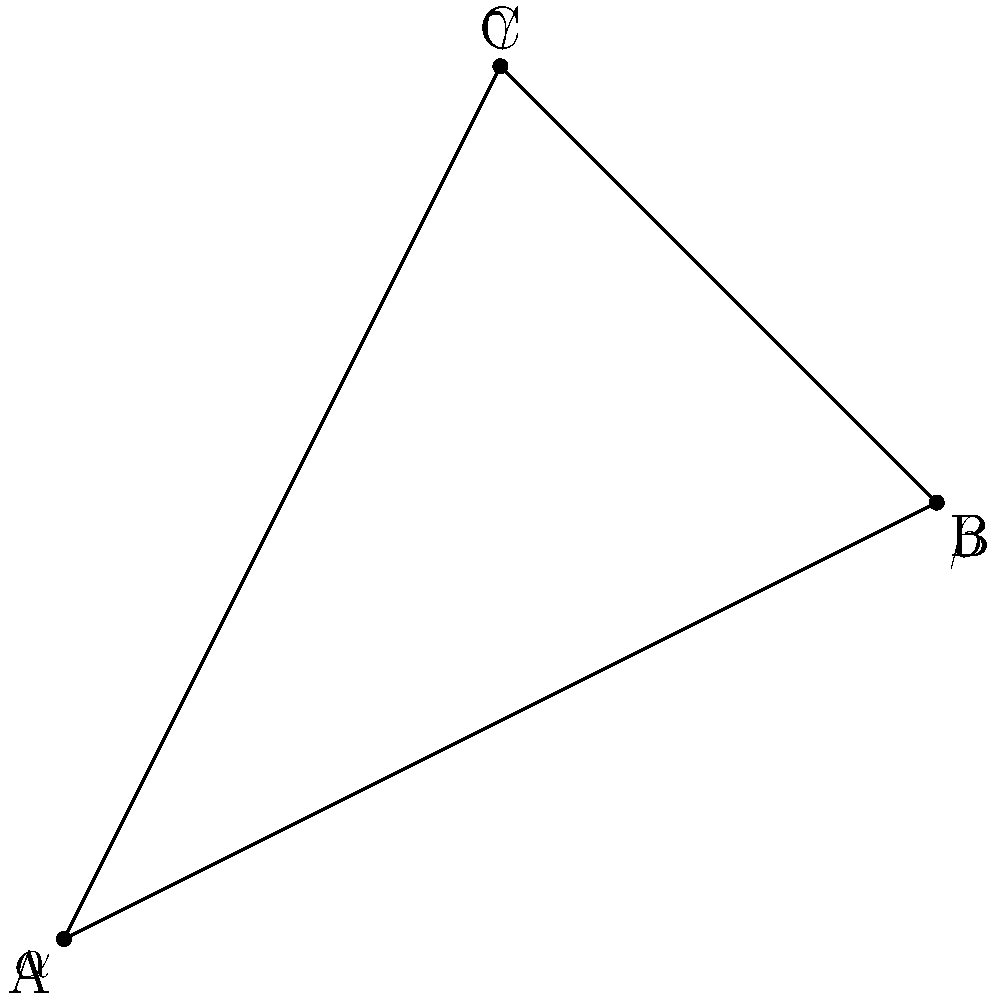In this hyperbolic triangle representing key locations in Cotta (A: Hebbelplatz, B: Gottfried-Keller-Straße, C: Ockerwitzer Straße), what is the sum of the interior angles $\alpha + \beta + \gamma$? To determine the sum of interior angles in a hyperbolic triangle, we need to follow these steps:

1. Recall that in Euclidean geometry, the sum of interior angles of a triangle is always 180°.

2. In hyperbolic geometry, however, this sum is always less than 180°. This is a fundamental property of hyperbolic triangles.

3. The exact sum depends on the area of the triangle. In hyperbolic geometry, there's a direct relationship between the area of a triangle and its angle defect (the difference between 180° and the sum of its angles).

4. The formula for this relationship is:

   $$ A = (\pi - (\alpha + \beta + \gamma))R^2 $$

   Where $A$ is the area of the triangle, $\alpha$, $\beta$, and $\gamma$ are the interior angles, and $R$ is the radius of curvature of the hyperbolic plane.

5. Since the area of a hyperbolic triangle is always positive, we can conclude that:

   $$ \pi > \alpha + \beta + \gamma $$

6. Converting this to degrees:

   $$ 180° > \alpha + \beta + \gamma $$

Therefore, while we can't determine the exact sum without more information about the specific hyperbolic plane and triangle, we can definitively state that the sum of the interior angles in this hyperbolic triangle representing locations in Cotta is less than 180°.
Answer: Less than 180° 